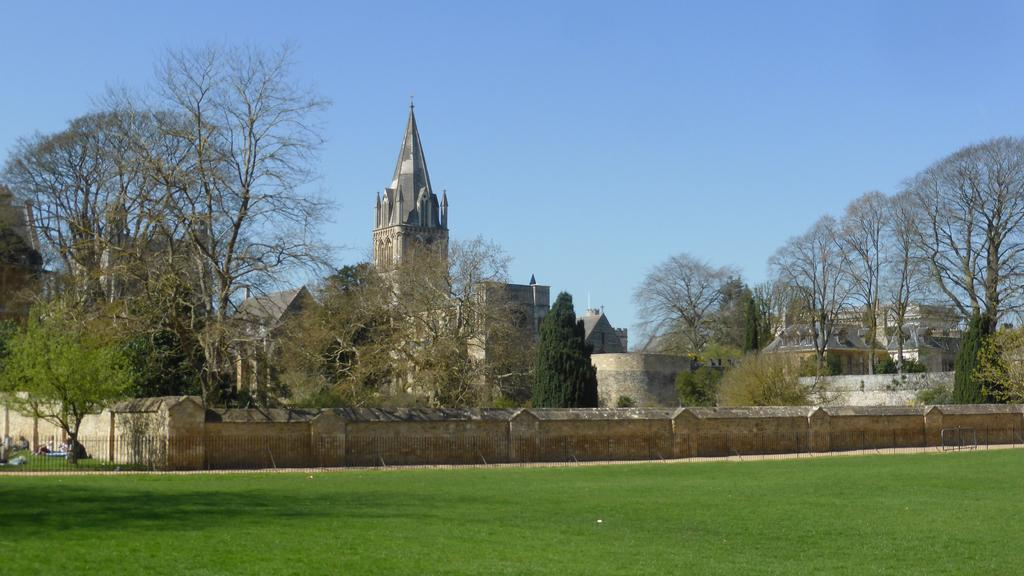What can be seen in the center of the image? The sky is visible in the center of the image. What type of natural elements are present in the image? There are trees and grass visible in the image. What type of man-made structures can be seen in the image? There are buildings and fences present in the image. Are there any living beings in the image? Yes, there are people in the image. Can you describe any other objects in the image? There are a few other objects in the image, but their specific details are not mentioned in the provided facts. What type of glass is being used by the servant in the image? There is no servant or glass present in the image. What rule is being enforced by the person in the image? There is no person enforcing a rule in the image; the image does not depict any specific situation or event. 